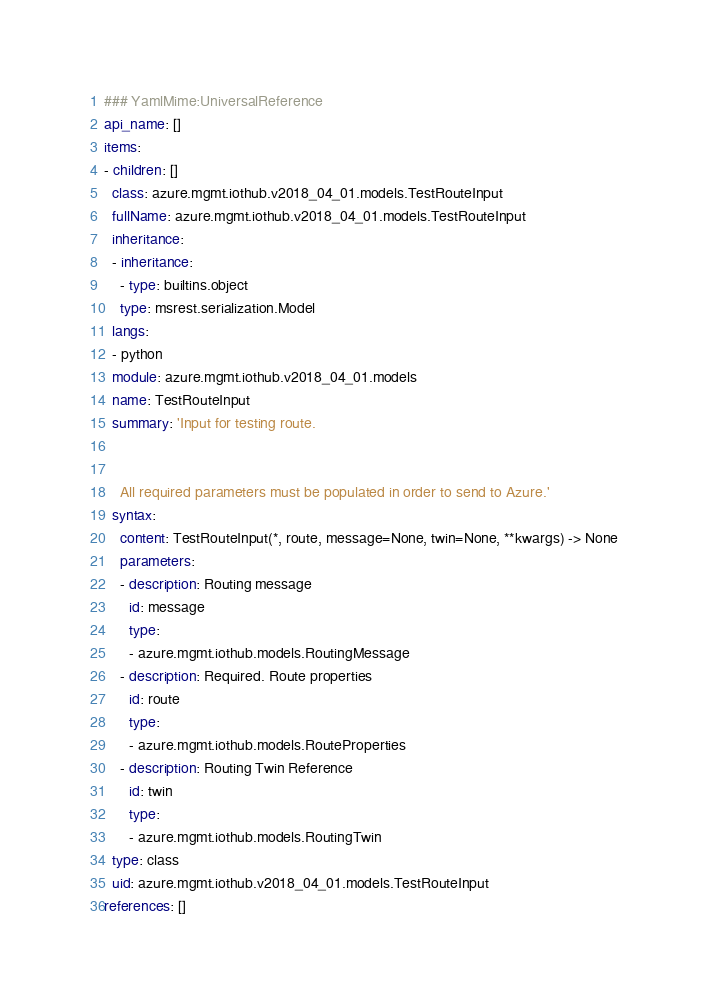Convert code to text. <code><loc_0><loc_0><loc_500><loc_500><_YAML_>### YamlMime:UniversalReference
api_name: []
items:
- children: []
  class: azure.mgmt.iothub.v2018_04_01.models.TestRouteInput
  fullName: azure.mgmt.iothub.v2018_04_01.models.TestRouteInput
  inheritance:
  - inheritance:
    - type: builtins.object
    type: msrest.serialization.Model
  langs:
  - python
  module: azure.mgmt.iothub.v2018_04_01.models
  name: TestRouteInput
  summary: 'Input for testing route.


    All required parameters must be populated in order to send to Azure.'
  syntax:
    content: TestRouteInput(*, route, message=None, twin=None, **kwargs) -> None
    parameters:
    - description: Routing message
      id: message
      type:
      - azure.mgmt.iothub.models.RoutingMessage
    - description: Required. Route properties
      id: route
      type:
      - azure.mgmt.iothub.models.RouteProperties
    - description: Routing Twin Reference
      id: twin
      type:
      - azure.mgmt.iothub.models.RoutingTwin
  type: class
  uid: azure.mgmt.iothub.v2018_04_01.models.TestRouteInput
references: []
</code> 